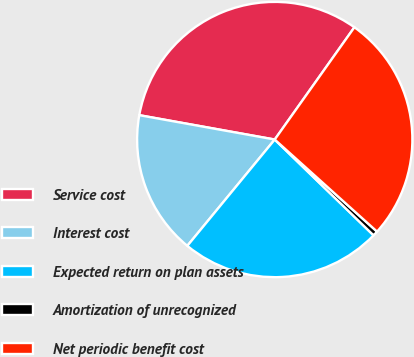Convert chart to OTSL. <chart><loc_0><loc_0><loc_500><loc_500><pie_chart><fcel>Service cost<fcel>Interest cost<fcel>Expected return on plan assets<fcel>Amortization of unrecognized<fcel>Net periodic benefit cost<nl><fcel>31.99%<fcel>16.88%<fcel>23.7%<fcel>0.59%<fcel>26.84%<nl></chart> 